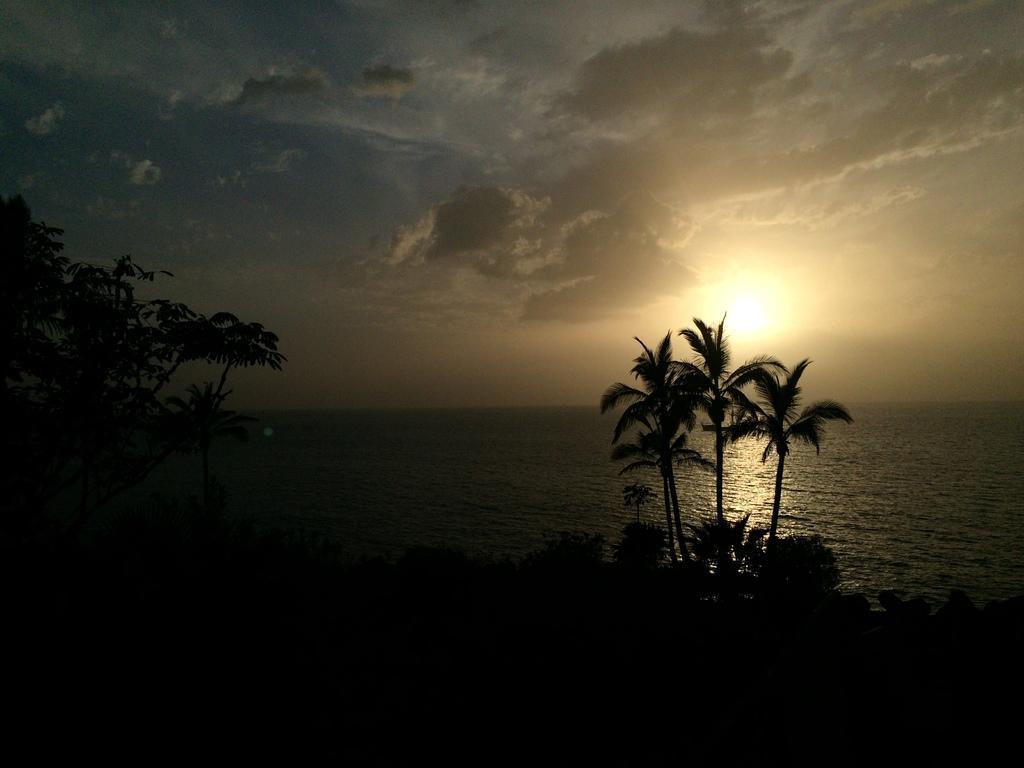How would you summarize this image in a sentence or two? As we can see in the image there are trees, water, sky, clouds and the image is little dark. 